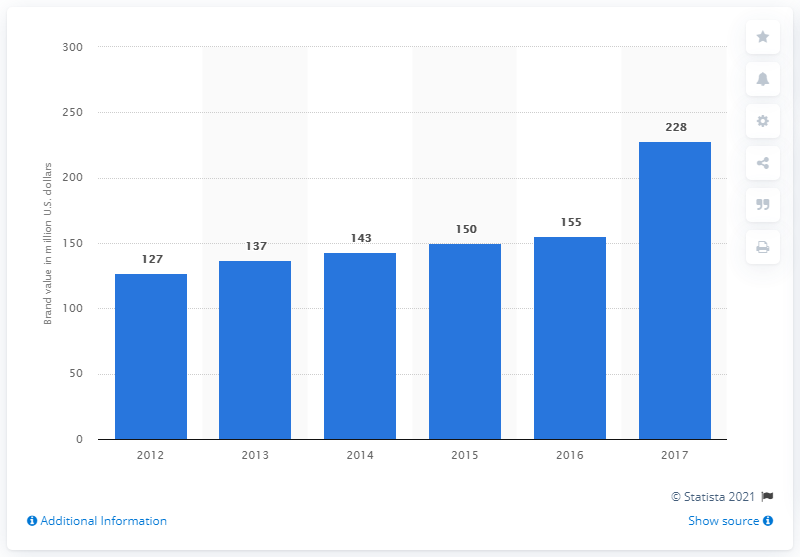Indicate a few pertinent items in this graphic. The brand value of the NCAA Men's Final Four in 2017 was estimated to be approximately 228. 